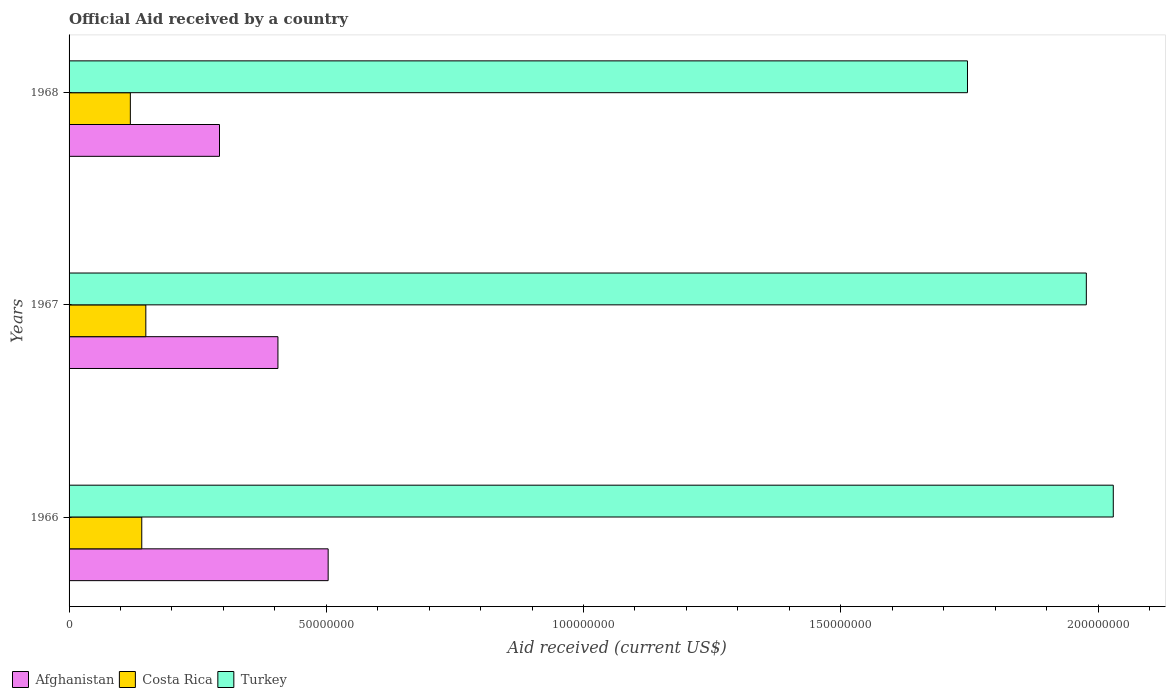How many groups of bars are there?
Offer a very short reply. 3. Are the number of bars per tick equal to the number of legend labels?
Your response must be concise. Yes. Are the number of bars on each tick of the Y-axis equal?
Your response must be concise. Yes. How many bars are there on the 2nd tick from the top?
Ensure brevity in your answer.  3. How many bars are there on the 2nd tick from the bottom?
Offer a terse response. 3. What is the label of the 1st group of bars from the top?
Offer a very short reply. 1968. What is the net official aid received in Turkey in 1967?
Ensure brevity in your answer.  1.98e+08. Across all years, what is the maximum net official aid received in Costa Rica?
Ensure brevity in your answer.  1.49e+07. Across all years, what is the minimum net official aid received in Afghanistan?
Your answer should be very brief. 2.92e+07. In which year was the net official aid received in Afghanistan maximum?
Ensure brevity in your answer.  1966. In which year was the net official aid received in Costa Rica minimum?
Keep it short and to the point. 1968. What is the total net official aid received in Turkey in the graph?
Offer a terse response. 5.75e+08. What is the difference between the net official aid received in Afghanistan in 1967 and that in 1968?
Offer a terse response. 1.14e+07. What is the difference between the net official aid received in Costa Rica in 1967 and the net official aid received in Turkey in 1968?
Offer a very short reply. -1.60e+08. What is the average net official aid received in Costa Rica per year?
Keep it short and to the point. 1.37e+07. In the year 1968, what is the difference between the net official aid received in Afghanistan and net official aid received in Turkey?
Your answer should be compact. -1.45e+08. In how many years, is the net official aid received in Costa Rica greater than 100000000 US$?
Provide a succinct answer. 0. What is the ratio of the net official aid received in Turkey in 1966 to that in 1968?
Offer a very short reply. 1.16. Is the net official aid received in Afghanistan in 1967 less than that in 1968?
Provide a succinct answer. No. What is the difference between the highest and the second highest net official aid received in Turkey?
Your answer should be compact. 5.24e+06. What is the difference between the highest and the lowest net official aid received in Turkey?
Give a very brief answer. 2.83e+07. Is the sum of the net official aid received in Costa Rica in 1966 and 1967 greater than the maximum net official aid received in Turkey across all years?
Offer a terse response. No. What does the 1st bar from the top in 1967 represents?
Give a very brief answer. Turkey. Is it the case that in every year, the sum of the net official aid received in Costa Rica and net official aid received in Afghanistan is greater than the net official aid received in Turkey?
Your response must be concise. No. How many bars are there?
Provide a succinct answer. 9. Are all the bars in the graph horizontal?
Offer a terse response. Yes. How many years are there in the graph?
Your answer should be very brief. 3. What is the difference between two consecutive major ticks on the X-axis?
Provide a short and direct response. 5.00e+07. Are the values on the major ticks of X-axis written in scientific E-notation?
Offer a terse response. No. Does the graph contain any zero values?
Your answer should be compact. No. Does the graph contain grids?
Provide a succinct answer. No. Where does the legend appear in the graph?
Provide a short and direct response. Bottom left. What is the title of the graph?
Offer a terse response. Official Aid received by a country. What is the label or title of the X-axis?
Your answer should be very brief. Aid received (current US$). What is the label or title of the Y-axis?
Make the answer very short. Years. What is the Aid received (current US$) in Afghanistan in 1966?
Offer a very short reply. 5.04e+07. What is the Aid received (current US$) in Costa Rica in 1966?
Provide a succinct answer. 1.41e+07. What is the Aid received (current US$) in Turkey in 1966?
Provide a succinct answer. 2.03e+08. What is the Aid received (current US$) in Afghanistan in 1967?
Ensure brevity in your answer.  4.06e+07. What is the Aid received (current US$) of Costa Rica in 1967?
Your answer should be very brief. 1.49e+07. What is the Aid received (current US$) of Turkey in 1967?
Make the answer very short. 1.98e+08. What is the Aid received (current US$) in Afghanistan in 1968?
Provide a succinct answer. 2.92e+07. What is the Aid received (current US$) of Costa Rica in 1968?
Your answer should be compact. 1.19e+07. What is the Aid received (current US$) of Turkey in 1968?
Give a very brief answer. 1.75e+08. Across all years, what is the maximum Aid received (current US$) of Afghanistan?
Make the answer very short. 5.04e+07. Across all years, what is the maximum Aid received (current US$) in Costa Rica?
Your answer should be very brief. 1.49e+07. Across all years, what is the maximum Aid received (current US$) of Turkey?
Your answer should be very brief. 2.03e+08. Across all years, what is the minimum Aid received (current US$) of Afghanistan?
Provide a short and direct response. 2.92e+07. Across all years, what is the minimum Aid received (current US$) in Costa Rica?
Provide a succinct answer. 1.19e+07. Across all years, what is the minimum Aid received (current US$) in Turkey?
Give a very brief answer. 1.75e+08. What is the total Aid received (current US$) in Afghanistan in the graph?
Your response must be concise. 1.20e+08. What is the total Aid received (current US$) of Costa Rica in the graph?
Provide a short and direct response. 4.10e+07. What is the total Aid received (current US$) of Turkey in the graph?
Provide a short and direct response. 5.75e+08. What is the difference between the Aid received (current US$) of Afghanistan in 1966 and that in 1967?
Your answer should be very brief. 9.76e+06. What is the difference between the Aid received (current US$) of Costa Rica in 1966 and that in 1967?
Ensure brevity in your answer.  -7.90e+05. What is the difference between the Aid received (current US$) in Turkey in 1966 and that in 1967?
Provide a short and direct response. 5.24e+06. What is the difference between the Aid received (current US$) of Afghanistan in 1966 and that in 1968?
Your response must be concise. 2.11e+07. What is the difference between the Aid received (current US$) in Costa Rica in 1966 and that in 1968?
Your answer should be compact. 2.22e+06. What is the difference between the Aid received (current US$) of Turkey in 1966 and that in 1968?
Your answer should be compact. 2.83e+07. What is the difference between the Aid received (current US$) of Afghanistan in 1967 and that in 1968?
Give a very brief answer. 1.14e+07. What is the difference between the Aid received (current US$) in Costa Rica in 1967 and that in 1968?
Give a very brief answer. 3.01e+06. What is the difference between the Aid received (current US$) of Turkey in 1967 and that in 1968?
Offer a terse response. 2.31e+07. What is the difference between the Aid received (current US$) of Afghanistan in 1966 and the Aid received (current US$) of Costa Rica in 1967?
Provide a succinct answer. 3.54e+07. What is the difference between the Aid received (current US$) of Afghanistan in 1966 and the Aid received (current US$) of Turkey in 1967?
Give a very brief answer. -1.47e+08. What is the difference between the Aid received (current US$) in Costa Rica in 1966 and the Aid received (current US$) in Turkey in 1967?
Provide a short and direct response. -1.84e+08. What is the difference between the Aid received (current US$) of Afghanistan in 1966 and the Aid received (current US$) of Costa Rica in 1968?
Provide a short and direct response. 3.84e+07. What is the difference between the Aid received (current US$) of Afghanistan in 1966 and the Aid received (current US$) of Turkey in 1968?
Provide a short and direct response. -1.24e+08. What is the difference between the Aid received (current US$) in Costa Rica in 1966 and the Aid received (current US$) in Turkey in 1968?
Offer a terse response. -1.60e+08. What is the difference between the Aid received (current US$) in Afghanistan in 1967 and the Aid received (current US$) in Costa Rica in 1968?
Provide a succinct answer. 2.87e+07. What is the difference between the Aid received (current US$) in Afghanistan in 1967 and the Aid received (current US$) in Turkey in 1968?
Keep it short and to the point. -1.34e+08. What is the difference between the Aid received (current US$) of Costa Rica in 1967 and the Aid received (current US$) of Turkey in 1968?
Your answer should be compact. -1.60e+08. What is the average Aid received (current US$) of Afghanistan per year?
Keep it short and to the point. 4.01e+07. What is the average Aid received (current US$) in Costa Rica per year?
Ensure brevity in your answer.  1.37e+07. What is the average Aid received (current US$) of Turkey per year?
Your answer should be compact. 1.92e+08. In the year 1966, what is the difference between the Aid received (current US$) of Afghanistan and Aid received (current US$) of Costa Rica?
Offer a terse response. 3.62e+07. In the year 1966, what is the difference between the Aid received (current US$) in Afghanistan and Aid received (current US$) in Turkey?
Your answer should be compact. -1.53e+08. In the year 1966, what is the difference between the Aid received (current US$) of Costa Rica and Aid received (current US$) of Turkey?
Offer a terse response. -1.89e+08. In the year 1967, what is the difference between the Aid received (current US$) of Afghanistan and Aid received (current US$) of Costa Rica?
Provide a short and direct response. 2.57e+07. In the year 1967, what is the difference between the Aid received (current US$) in Afghanistan and Aid received (current US$) in Turkey?
Your answer should be very brief. -1.57e+08. In the year 1967, what is the difference between the Aid received (current US$) in Costa Rica and Aid received (current US$) in Turkey?
Keep it short and to the point. -1.83e+08. In the year 1968, what is the difference between the Aid received (current US$) in Afghanistan and Aid received (current US$) in Costa Rica?
Your answer should be compact. 1.73e+07. In the year 1968, what is the difference between the Aid received (current US$) in Afghanistan and Aid received (current US$) in Turkey?
Provide a short and direct response. -1.45e+08. In the year 1968, what is the difference between the Aid received (current US$) in Costa Rica and Aid received (current US$) in Turkey?
Your answer should be very brief. -1.63e+08. What is the ratio of the Aid received (current US$) of Afghanistan in 1966 to that in 1967?
Offer a terse response. 1.24. What is the ratio of the Aid received (current US$) of Costa Rica in 1966 to that in 1967?
Keep it short and to the point. 0.95. What is the ratio of the Aid received (current US$) in Turkey in 1966 to that in 1967?
Provide a short and direct response. 1.03. What is the ratio of the Aid received (current US$) of Afghanistan in 1966 to that in 1968?
Offer a very short reply. 1.72. What is the ratio of the Aid received (current US$) of Costa Rica in 1966 to that in 1968?
Offer a terse response. 1.19. What is the ratio of the Aid received (current US$) of Turkey in 1966 to that in 1968?
Offer a terse response. 1.16. What is the ratio of the Aid received (current US$) in Afghanistan in 1967 to that in 1968?
Offer a terse response. 1.39. What is the ratio of the Aid received (current US$) of Costa Rica in 1967 to that in 1968?
Provide a succinct answer. 1.25. What is the ratio of the Aid received (current US$) of Turkey in 1967 to that in 1968?
Provide a short and direct response. 1.13. What is the difference between the highest and the second highest Aid received (current US$) in Afghanistan?
Keep it short and to the point. 9.76e+06. What is the difference between the highest and the second highest Aid received (current US$) of Costa Rica?
Give a very brief answer. 7.90e+05. What is the difference between the highest and the second highest Aid received (current US$) in Turkey?
Keep it short and to the point. 5.24e+06. What is the difference between the highest and the lowest Aid received (current US$) of Afghanistan?
Offer a very short reply. 2.11e+07. What is the difference between the highest and the lowest Aid received (current US$) in Costa Rica?
Your answer should be very brief. 3.01e+06. What is the difference between the highest and the lowest Aid received (current US$) of Turkey?
Your response must be concise. 2.83e+07. 